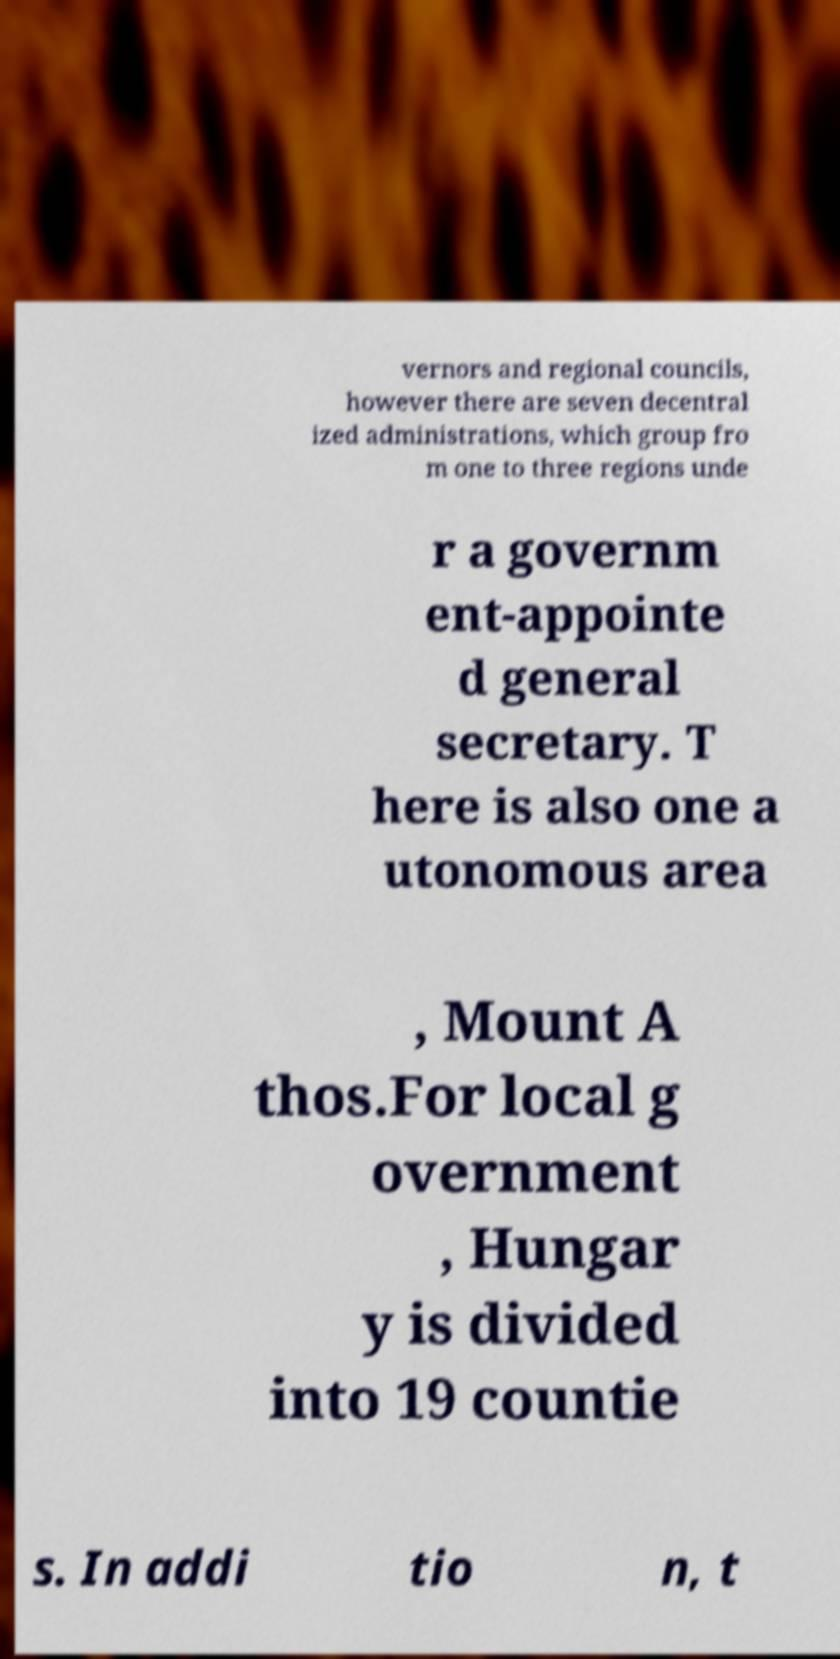Please read and relay the text visible in this image. What does it say? vernors and regional councils, however there are seven decentral ized administrations, which group fro m one to three regions unde r a governm ent-appointe d general secretary. T here is also one a utonomous area , Mount A thos.For local g overnment , Hungar y is divided into 19 countie s. In addi tio n, t 